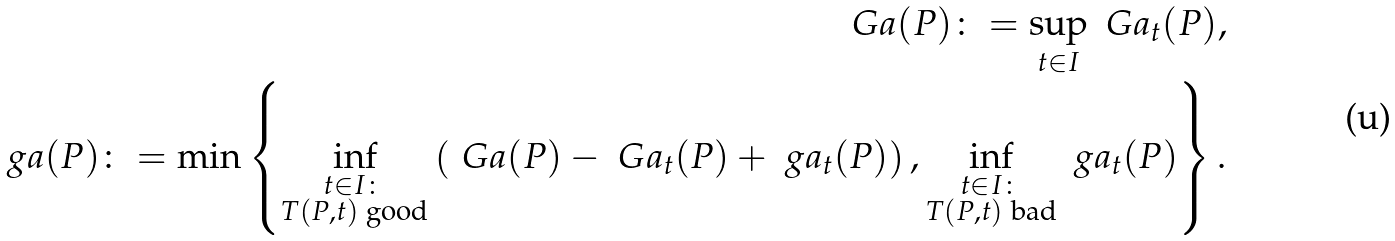<formula> <loc_0><loc_0><loc_500><loc_500>\ G a ( P ) \colon = \sup _ { t \in I } \ G a _ { t } ( P ) , \\ \ g a ( P ) \colon = \min \left \{ \inf _ { \substack { t \in I \colon \\ T ( P , t ) \text { good} } } \left ( \ G a ( P ) - \ G a _ { t } ( P ) + \ g a _ { t } ( P ) \right ) , \inf _ { \substack { t \in I \colon \\ T ( P , t ) \text { bad} } } \ g a _ { t } ( P ) \right \} .</formula> 